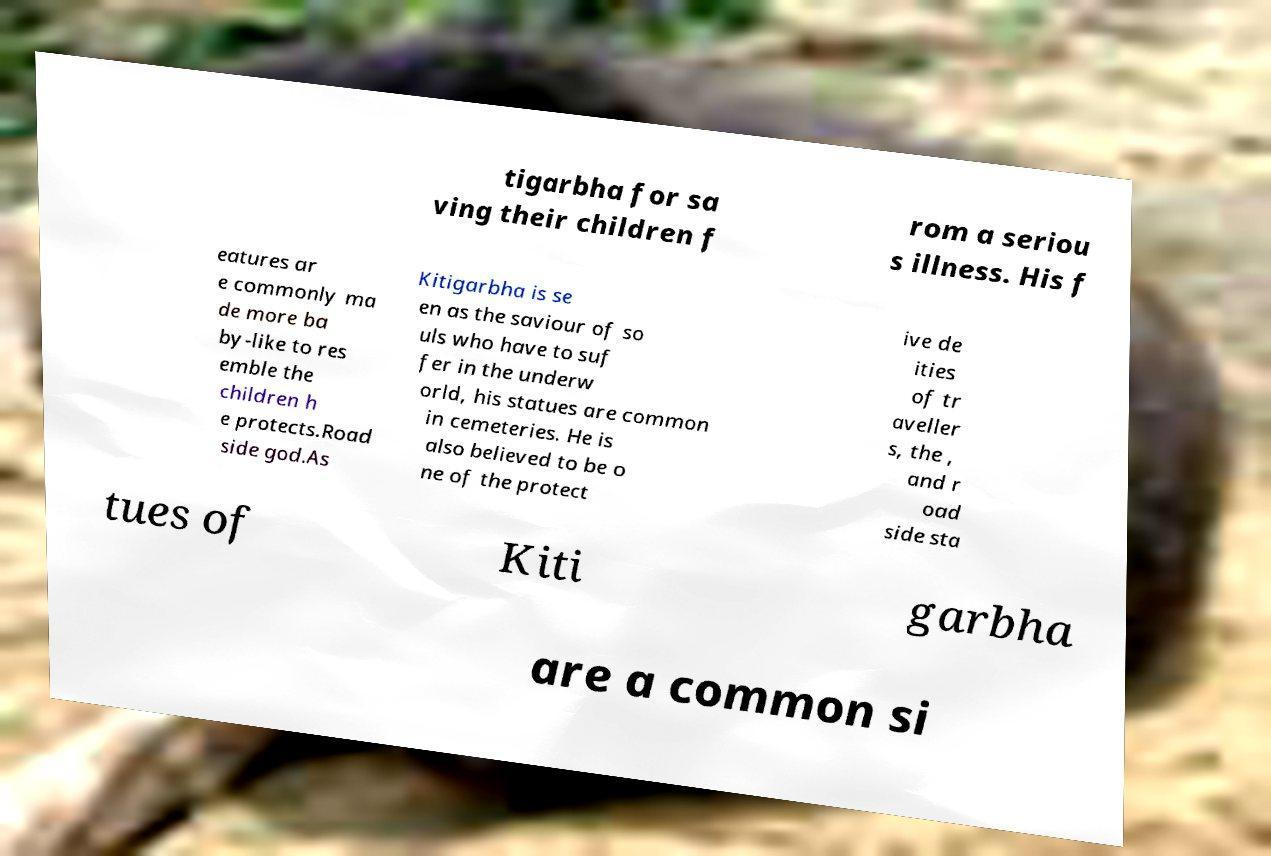There's text embedded in this image that I need extracted. Can you transcribe it verbatim? tigarbha for sa ving their children f rom a seriou s illness. His f eatures ar e commonly ma de more ba by-like to res emble the children h e protects.Road side god.As Kitigarbha is se en as the saviour of so uls who have to suf fer in the underw orld, his statues are common in cemeteries. He is also believed to be o ne of the protect ive de ities of tr aveller s, the , and r oad side sta tues of Kiti garbha are a common si 